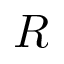Convert formula to latex. <formula><loc_0><loc_0><loc_500><loc_500>R</formula> 